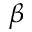Convert formula to latex. <formula><loc_0><loc_0><loc_500><loc_500>\beta</formula> 